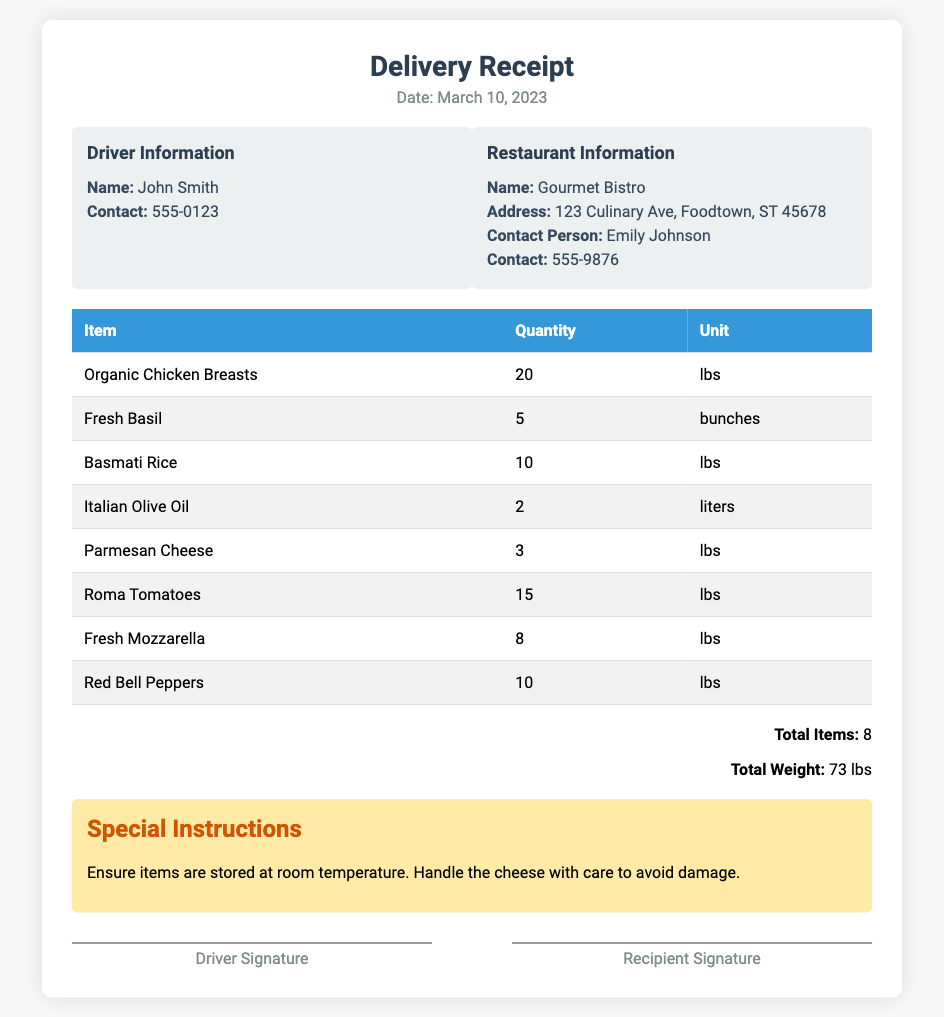What is the date of the delivery? The date of the delivery is stated in the header section of the document.
Answer: March 10, 2023 Who is the driver? The driver's name is provided in the driver information section of the document.
Answer: John Smith How many lbs of Organic Chicken Breasts were delivered? The quantity of Organic Chicken Breasts is listed in the itemized table.
Answer: 20 What is the total weight of the items delivered? The total weight is summarized at the end of the itemized listing in the totals section.
Answer: 73 lbs What is the contact number for the restaurant? The contact number for the restaurant is found in the restaurant information section of the document.
Answer: 555-9876 Which item has the highest quantity delivered? The item with the highest quantity can be determined by reviewing the quantities in the table.
Answer: Organic Chicken Breasts What special instructions were given for the delivery? The special instructions are mentioned in a dedicated section of the document.
Answer: Ensure items are stored at room temperature. Handle the cheese with care to avoid damage How many items are listed in total? The total items count is provided in the totals section at the bottom of the document.
Answer: 8 